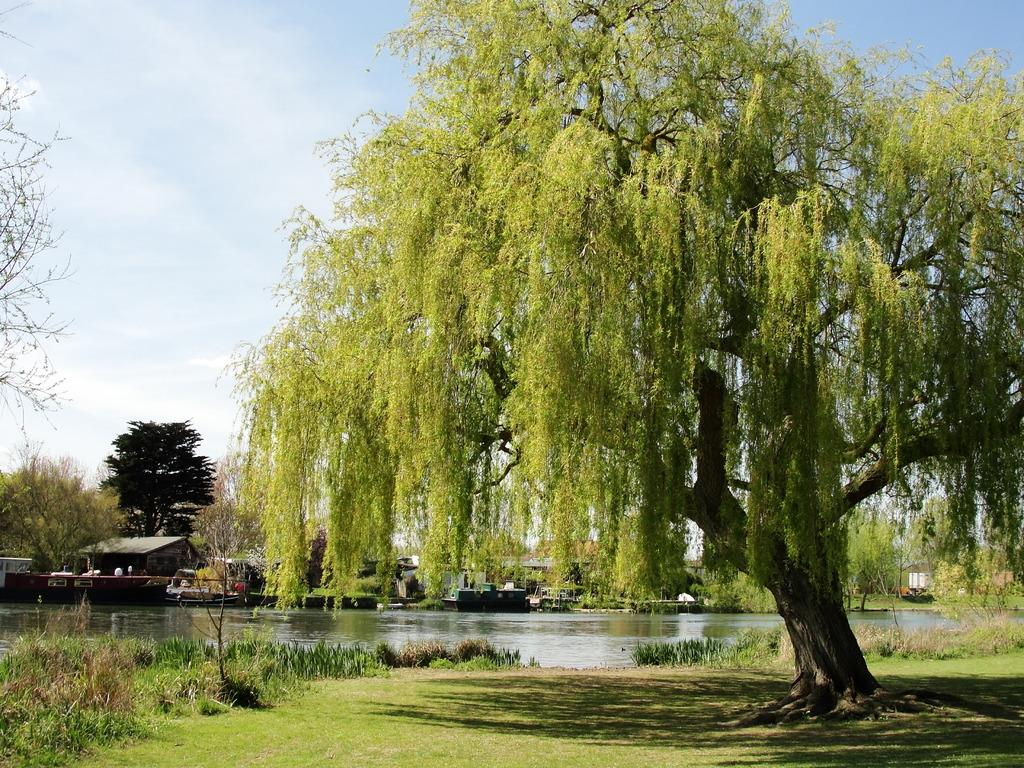What type of vegetation can be seen in the image? There are trees in the image. What type of structures are present in the image? There are sheds in the image. What type of vehicles are in the image? There are boats in the image. What is visible at the bottom of the image? There is water and ground visible at the bottom of the image. What is visible in the sky at the top of the image? There are clouds in the sky at the top of the image. What type of paper is floating on the water in the image? There is no paper visible in the image; it only features trees, sheds, boats, water, ground, and clouds. 